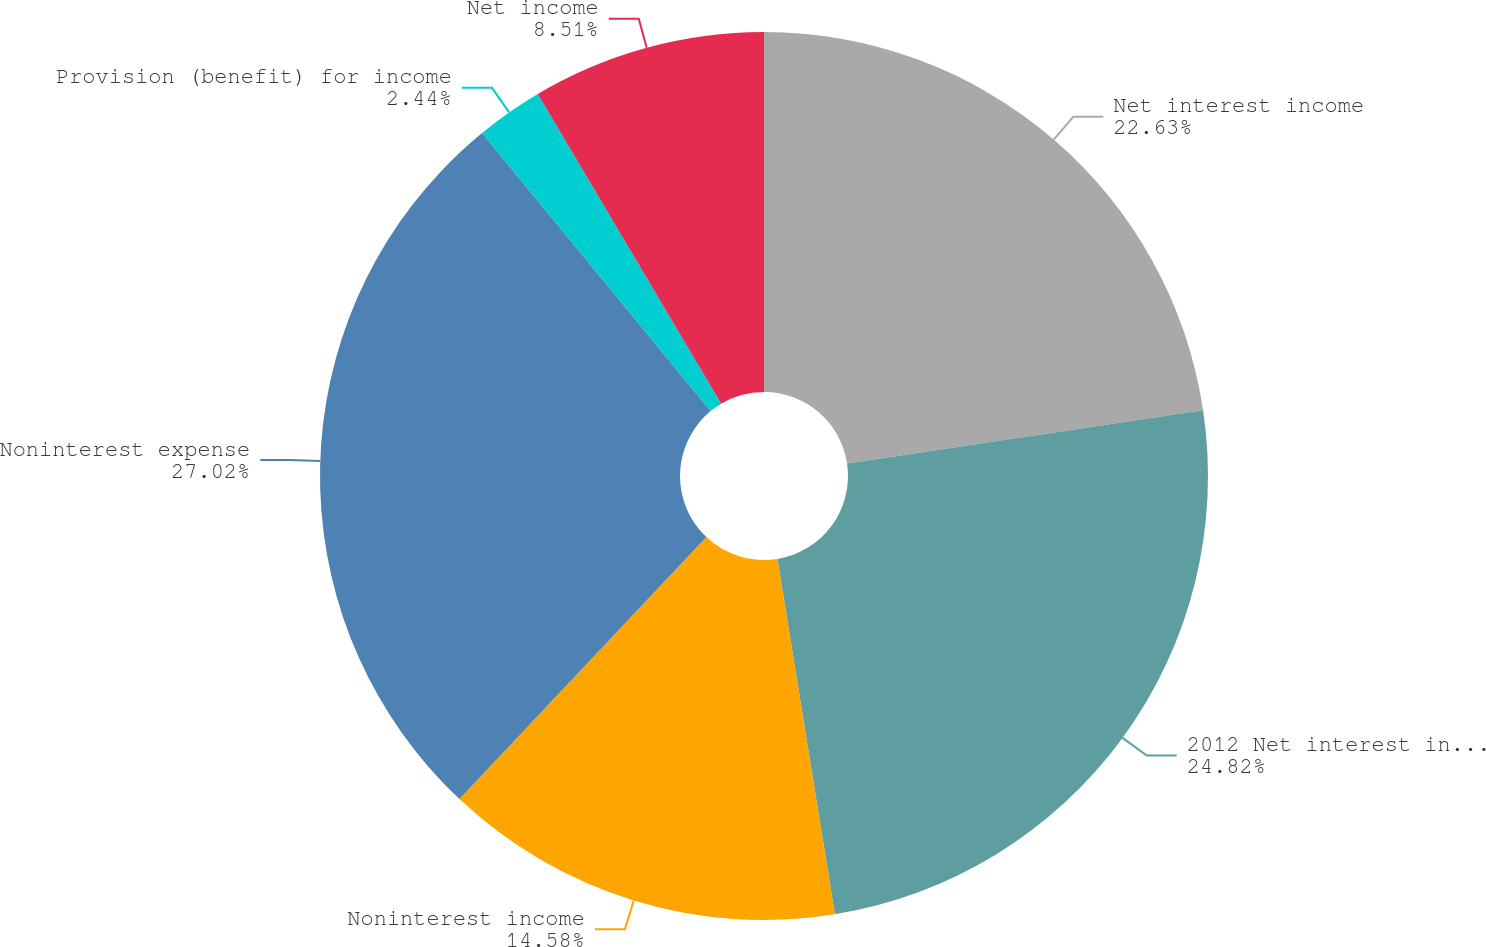<chart> <loc_0><loc_0><loc_500><loc_500><pie_chart><fcel>Net interest income<fcel>2012 Net interest income<fcel>Noninterest income<fcel>Noninterest expense<fcel>Provision (benefit) for income<fcel>Net income<nl><fcel>22.63%<fcel>24.82%<fcel>14.58%<fcel>27.02%<fcel>2.44%<fcel>8.51%<nl></chart> 